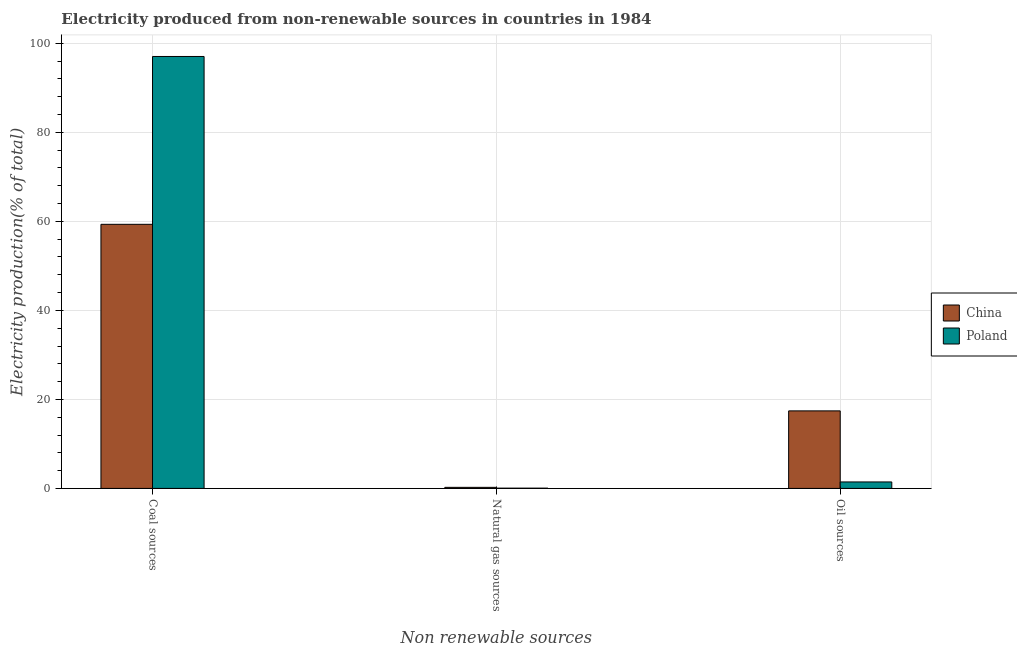How many groups of bars are there?
Your answer should be very brief. 3. How many bars are there on the 3rd tick from the right?
Provide a succinct answer. 2. What is the label of the 2nd group of bars from the left?
Keep it short and to the point. Natural gas sources. What is the percentage of electricity produced by natural gas in China?
Provide a short and direct response. 0.24. Across all countries, what is the maximum percentage of electricity produced by coal?
Your answer should be very brief. 97.06. Across all countries, what is the minimum percentage of electricity produced by oil sources?
Make the answer very short. 1.45. In which country was the percentage of electricity produced by oil sources minimum?
Give a very brief answer. Poland. What is the total percentage of electricity produced by oil sources in the graph?
Provide a succinct answer. 18.88. What is the difference between the percentage of electricity produced by coal in China and that in Poland?
Offer a very short reply. -37.71. What is the difference between the percentage of electricity produced by oil sources in Poland and the percentage of electricity produced by coal in China?
Your answer should be very brief. -57.89. What is the average percentage of electricity produced by coal per country?
Your answer should be very brief. 78.2. What is the difference between the percentage of electricity produced by oil sources and percentage of electricity produced by natural gas in China?
Offer a very short reply. 17.18. What is the ratio of the percentage of electricity produced by coal in Poland to that in China?
Your answer should be very brief. 1.64. Is the difference between the percentage of electricity produced by natural gas in Poland and China greater than the difference between the percentage of electricity produced by coal in Poland and China?
Keep it short and to the point. No. What is the difference between the highest and the second highest percentage of electricity produced by oil sources?
Ensure brevity in your answer.  15.97. What is the difference between the highest and the lowest percentage of electricity produced by oil sources?
Keep it short and to the point. 15.97. What does the 2nd bar from the right in Oil sources represents?
Keep it short and to the point. China. Is it the case that in every country, the sum of the percentage of electricity produced by coal and percentage of electricity produced by natural gas is greater than the percentage of electricity produced by oil sources?
Your answer should be compact. Yes. Are all the bars in the graph horizontal?
Keep it short and to the point. No. What is the difference between two consecutive major ticks on the Y-axis?
Your answer should be very brief. 20. Does the graph contain any zero values?
Give a very brief answer. No. Does the graph contain grids?
Your answer should be very brief. Yes. Where does the legend appear in the graph?
Offer a very short reply. Center right. How are the legend labels stacked?
Keep it short and to the point. Vertical. What is the title of the graph?
Provide a short and direct response. Electricity produced from non-renewable sources in countries in 1984. Does "Benin" appear as one of the legend labels in the graph?
Ensure brevity in your answer.  No. What is the label or title of the X-axis?
Offer a very short reply. Non renewable sources. What is the label or title of the Y-axis?
Ensure brevity in your answer.  Electricity production(% of total). What is the Electricity production(% of total) in China in Coal sources?
Provide a succinct answer. 59.34. What is the Electricity production(% of total) of Poland in Coal sources?
Make the answer very short. 97.06. What is the Electricity production(% of total) in China in Natural gas sources?
Keep it short and to the point. 0.24. What is the Electricity production(% of total) in Poland in Natural gas sources?
Ensure brevity in your answer.  0.06. What is the Electricity production(% of total) in China in Oil sources?
Offer a very short reply. 17.42. What is the Electricity production(% of total) of Poland in Oil sources?
Give a very brief answer. 1.45. Across all Non renewable sources, what is the maximum Electricity production(% of total) in China?
Your answer should be compact. 59.34. Across all Non renewable sources, what is the maximum Electricity production(% of total) of Poland?
Ensure brevity in your answer.  97.06. Across all Non renewable sources, what is the minimum Electricity production(% of total) in China?
Your response must be concise. 0.24. Across all Non renewable sources, what is the minimum Electricity production(% of total) of Poland?
Your answer should be very brief. 0.06. What is the total Electricity production(% of total) in China in the graph?
Make the answer very short. 77.01. What is the total Electricity production(% of total) in Poland in the graph?
Your response must be concise. 98.57. What is the difference between the Electricity production(% of total) in China in Coal sources and that in Natural gas sources?
Your answer should be compact. 59.1. What is the difference between the Electricity production(% of total) of Poland in Coal sources and that in Natural gas sources?
Keep it short and to the point. 97. What is the difference between the Electricity production(% of total) in China in Coal sources and that in Oil sources?
Give a very brief answer. 41.92. What is the difference between the Electricity production(% of total) in Poland in Coal sources and that in Oil sources?
Provide a short and direct response. 95.6. What is the difference between the Electricity production(% of total) in China in Natural gas sources and that in Oil sources?
Offer a terse response. -17.18. What is the difference between the Electricity production(% of total) in Poland in Natural gas sources and that in Oil sources?
Provide a short and direct response. -1.4. What is the difference between the Electricity production(% of total) in China in Coal sources and the Electricity production(% of total) in Poland in Natural gas sources?
Provide a succinct answer. 59.29. What is the difference between the Electricity production(% of total) of China in Coal sources and the Electricity production(% of total) of Poland in Oil sources?
Offer a terse response. 57.89. What is the difference between the Electricity production(% of total) of China in Natural gas sources and the Electricity production(% of total) of Poland in Oil sources?
Offer a very short reply. -1.21. What is the average Electricity production(% of total) in China per Non renewable sources?
Provide a succinct answer. 25.67. What is the average Electricity production(% of total) in Poland per Non renewable sources?
Keep it short and to the point. 32.86. What is the difference between the Electricity production(% of total) of China and Electricity production(% of total) of Poland in Coal sources?
Keep it short and to the point. -37.71. What is the difference between the Electricity production(% of total) in China and Electricity production(% of total) in Poland in Natural gas sources?
Offer a very short reply. 0.18. What is the difference between the Electricity production(% of total) of China and Electricity production(% of total) of Poland in Oil sources?
Make the answer very short. 15.97. What is the ratio of the Electricity production(% of total) in China in Coal sources to that in Natural gas sources?
Make the answer very short. 246.37. What is the ratio of the Electricity production(% of total) of Poland in Coal sources to that in Natural gas sources?
Your answer should be compact. 1696.54. What is the ratio of the Electricity production(% of total) in China in Coal sources to that in Oil sources?
Your answer should be very brief. 3.41. What is the ratio of the Electricity production(% of total) in Poland in Coal sources to that in Oil sources?
Offer a terse response. 66.74. What is the ratio of the Electricity production(% of total) of China in Natural gas sources to that in Oil sources?
Provide a succinct answer. 0.01. What is the ratio of the Electricity production(% of total) of Poland in Natural gas sources to that in Oil sources?
Your answer should be very brief. 0.04. What is the difference between the highest and the second highest Electricity production(% of total) in China?
Give a very brief answer. 41.92. What is the difference between the highest and the second highest Electricity production(% of total) in Poland?
Give a very brief answer. 95.6. What is the difference between the highest and the lowest Electricity production(% of total) of China?
Ensure brevity in your answer.  59.1. What is the difference between the highest and the lowest Electricity production(% of total) of Poland?
Provide a short and direct response. 97. 